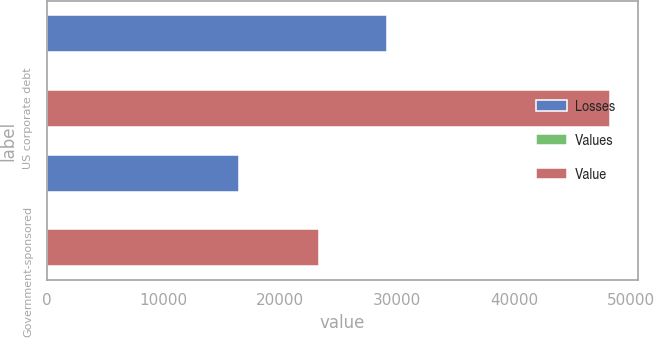Convert chart to OTSL. <chart><loc_0><loc_0><loc_500><loc_500><stacked_bar_chart><ecel><fcel>US corporate debt<fcel>Government-sponsored<nl><fcel>Losses<fcel>29118<fcel>16447<nl><fcel>Values<fcel>55<fcel>51<nl><fcel>Value<fcel>48163<fcel>23316<nl></chart> 